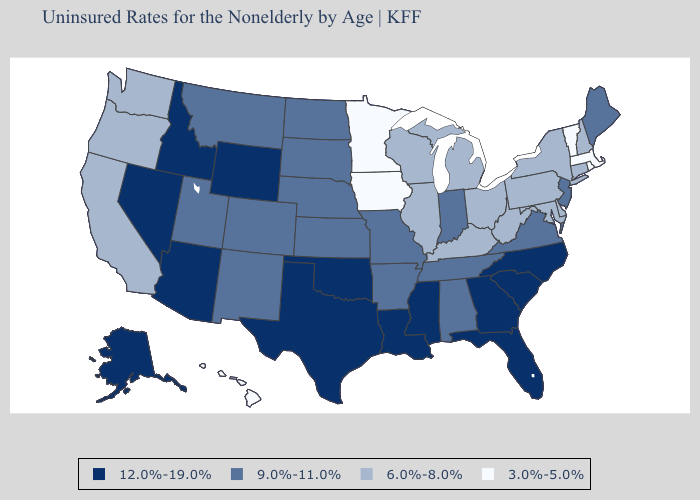What is the value of Florida?
Give a very brief answer. 12.0%-19.0%. Name the states that have a value in the range 9.0%-11.0%?
Give a very brief answer. Alabama, Arkansas, Colorado, Indiana, Kansas, Maine, Missouri, Montana, Nebraska, New Jersey, New Mexico, North Dakota, South Dakota, Tennessee, Utah, Virginia. What is the highest value in the USA?
Be succinct. 12.0%-19.0%. Name the states that have a value in the range 9.0%-11.0%?
Short answer required. Alabama, Arkansas, Colorado, Indiana, Kansas, Maine, Missouri, Montana, Nebraska, New Jersey, New Mexico, North Dakota, South Dakota, Tennessee, Utah, Virginia. Name the states that have a value in the range 6.0%-8.0%?
Quick response, please. California, Connecticut, Delaware, Illinois, Kentucky, Maryland, Michigan, New Hampshire, New York, Ohio, Oregon, Pennsylvania, Washington, West Virginia, Wisconsin. Name the states that have a value in the range 12.0%-19.0%?
Keep it brief. Alaska, Arizona, Florida, Georgia, Idaho, Louisiana, Mississippi, Nevada, North Carolina, Oklahoma, South Carolina, Texas, Wyoming. Name the states that have a value in the range 3.0%-5.0%?
Keep it brief. Hawaii, Iowa, Massachusetts, Minnesota, Rhode Island, Vermont. What is the value of West Virginia?
Give a very brief answer. 6.0%-8.0%. Does the first symbol in the legend represent the smallest category?
Keep it brief. No. What is the highest value in states that border Nevada?
Concise answer only. 12.0%-19.0%. What is the value of New Jersey?
Write a very short answer. 9.0%-11.0%. Does New Jersey have a higher value than Delaware?
Concise answer only. Yes. Does New Hampshire have the same value as Virginia?
Concise answer only. No. What is the lowest value in the West?
Be succinct. 3.0%-5.0%. Name the states that have a value in the range 3.0%-5.0%?
Short answer required. Hawaii, Iowa, Massachusetts, Minnesota, Rhode Island, Vermont. 